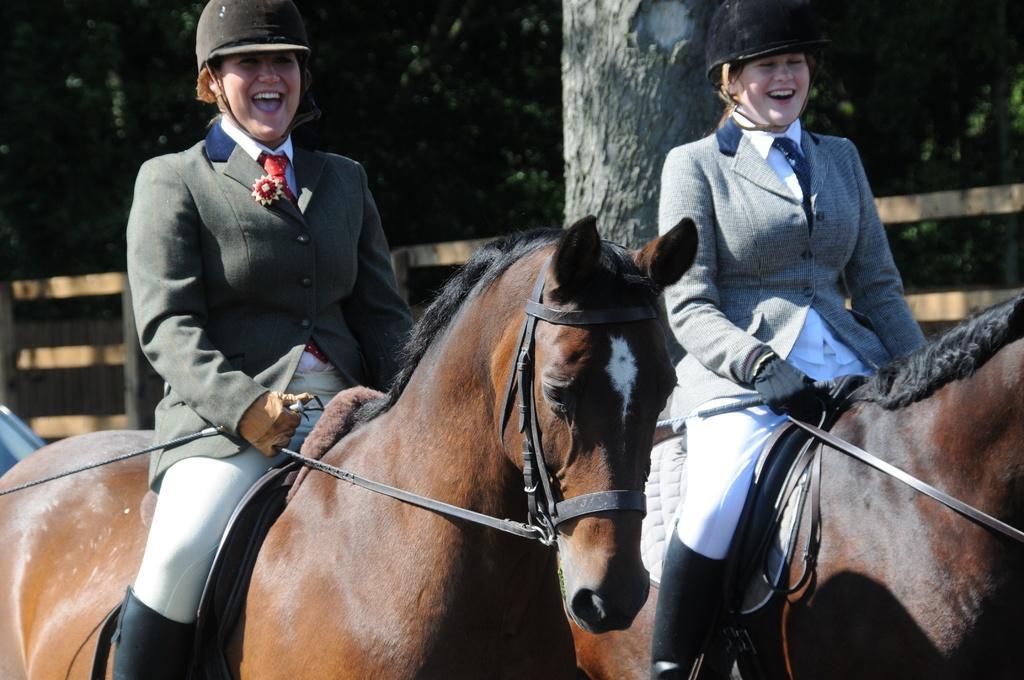Could you give a brief overview of what you see in this image? In this image we can see two ladies riding on the horses, they are holding the sticks, behind them there is a fencing and some trees. 